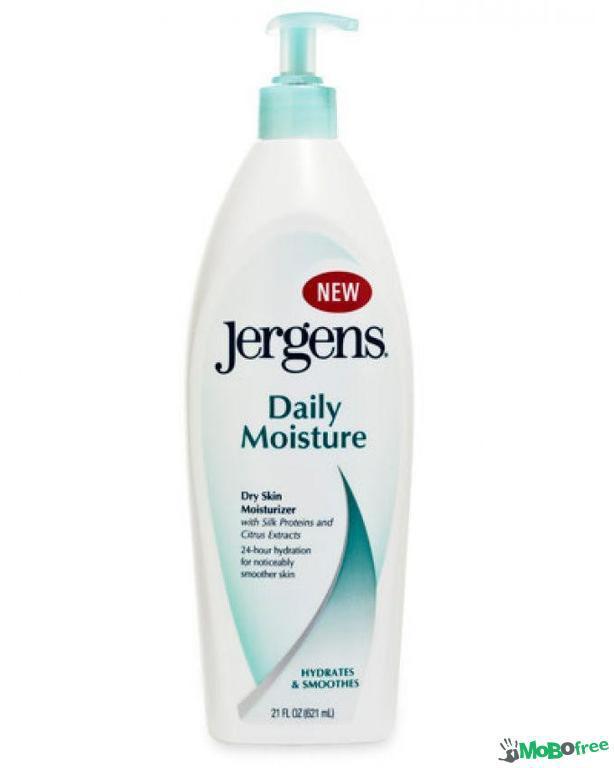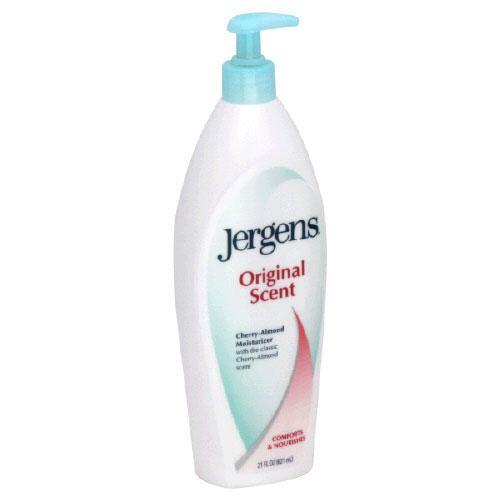The first image is the image on the left, the second image is the image on the right. Analyze the images presented: Is the assertion "The bottle in the image on the right is turned at a slight angle." valid? Answer yes or no. Yes. The first image is the image on the left, the second image is the image on the right. Examine the images to the left and right. Is the description "There are two bottles, and only one of them has a pump." accurate? Answer yes or no. No. 